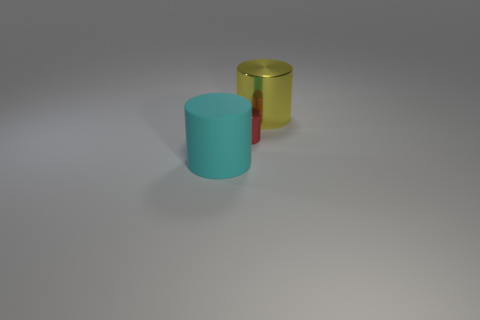Is there any other thing that is the same size as the red metallic cylinder?
Offer a terse response. No. There is a metallic cylinder left of the big thing that is right of the big object that is left of the tiny red object; what size is it?
Offer a very short reply. Small. There is a large cyan thing; is it the same shape as the big object that is behind the small metallic cylinder?
Your answer should be compact. Yes. Is there a large metal thing that has the same color as the big rubber thing?
Your response must be concise. No. How many cylinders are either big yellow objects or small metal things?
Your response must be concise. 2. Is there a large cyan rubber thing of the same shape as the yellow object?
Offer a very short reply. Yes. Are there fewer cyan rubber objects left of the large cyan cylinder than red matte spheres?
Ensure brevity in your answer.  No. How many large rubber things are there?
Make the answer very short. 1. How many small objects are the same material as the big cyan cylinder?
Give a very brief answer. 0. What number of objects are large cylinders to the left of the big yellow cylinder or small purple balls?
Ensure brevity in your answer.  1. 